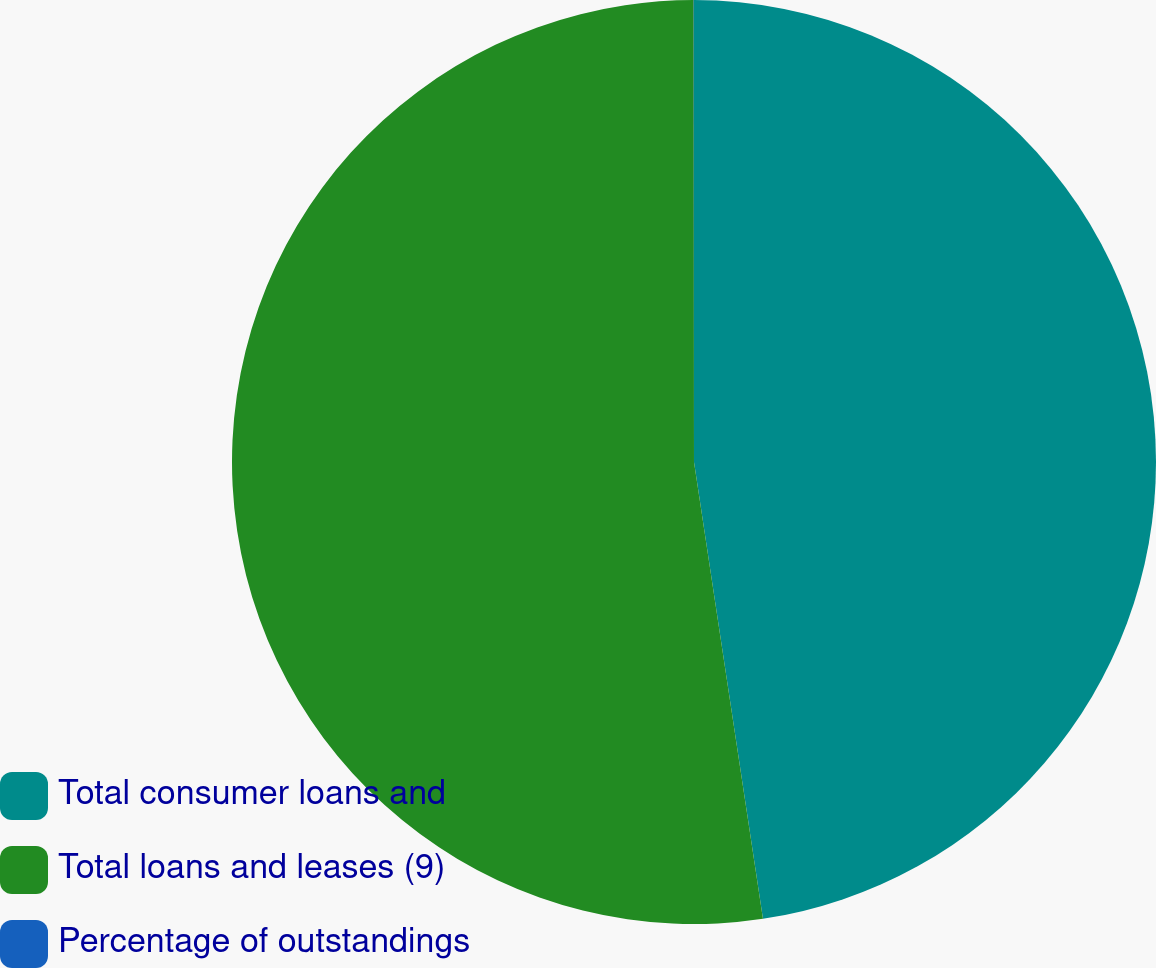Convert chart. <chart><loc_0><loc_0><loc_500><loc_500><pie_chart><fcel>Total consumer loans and<fcel>Total loans and leases (9)<fcel>Percentage of outstandings<nl><fcel>47.62%<fcel>52.38%<fcel>0.01%<nl></chart> 